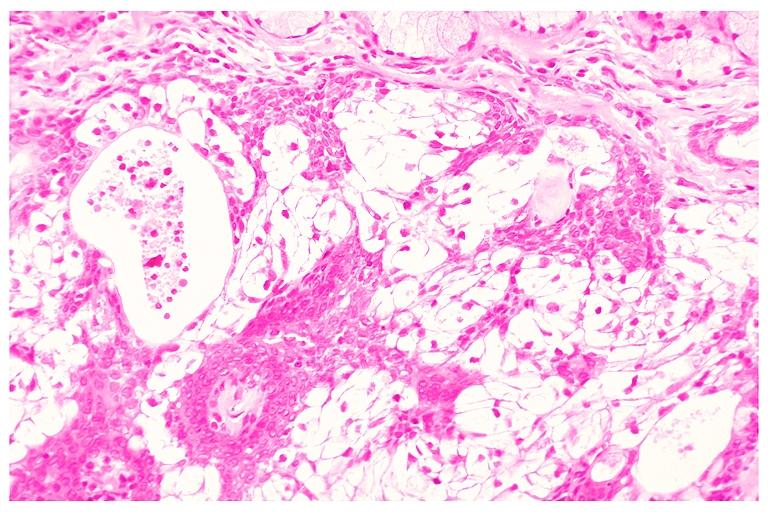what does this image show?
Answer the question using a single word or phrase. Mucoepidermoid carcinoma 